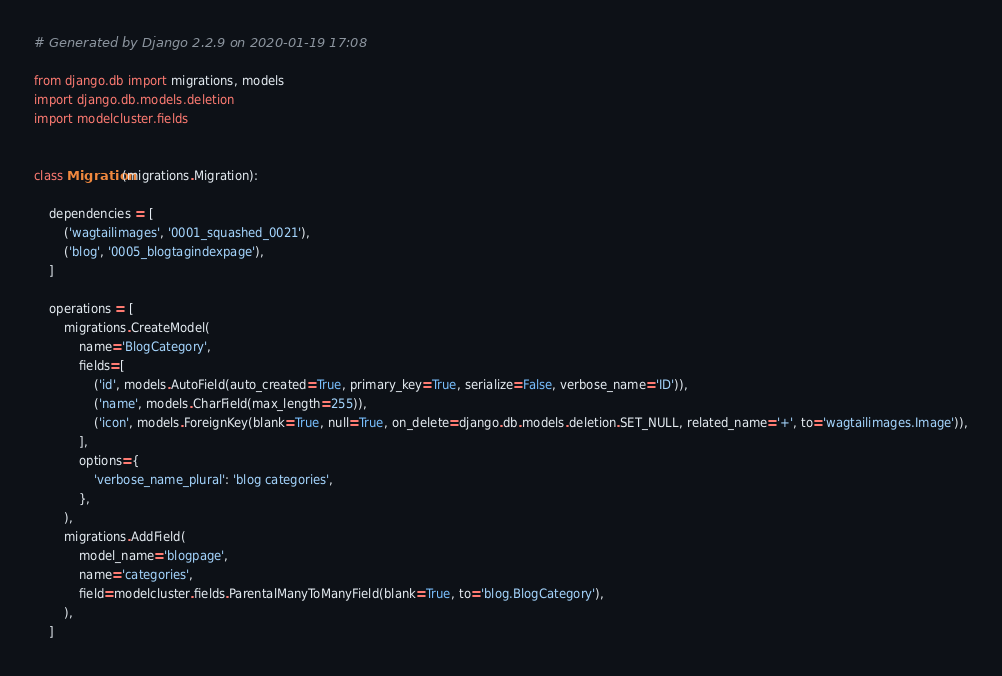<code> <loc_0><loc_0><loc_500><loc_500><_Python_># Generated by Django 2.2.9 on 2020-01-19 17:08

from django.db import migrations, models
import django.db.models.deletion
import modelcluster.fields


class Migration(migrations.Migration):

    dependencies = [
        ('wagtailimages', '0001_squashed_0021'),
        ('blog', '0005_blogtagindexpage'),
    ]

    operations = [
        migrations.CreateModel(
            name='BlogCategory',
            fields=[
                ('id', models.AutoField(auto_created=True, primary_key=True, serialize=False, verbose_name='ID')),
                ('name', models.CharField(max_length=255)),
                ('icon', models.ForeignKey(blank=True, null=True, on_delete=django.db.models.deletion.SET_NULL, related_name='+', to='wagtailimages.Image')),
            ],
            options={
                'verbose_name_plural': 'blog categories',
            },
        ),
        migrations.AddField(
            model_name='blogpage',
            name='categories',
            field=modelcluster.fields.ParentalManyToManyField(blank=True, to='blog.BlogCategory'),
        ),
    ]
</code> 